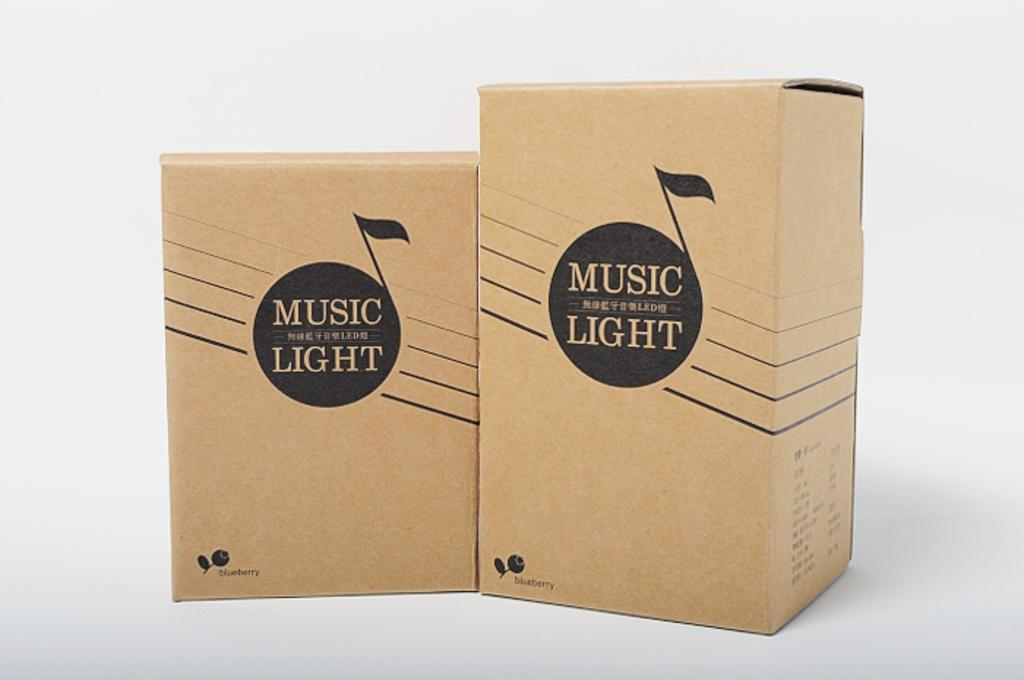<image>
Present a compact description of the photo's key features. Two cardboard boxes side by side which contain music lights. 